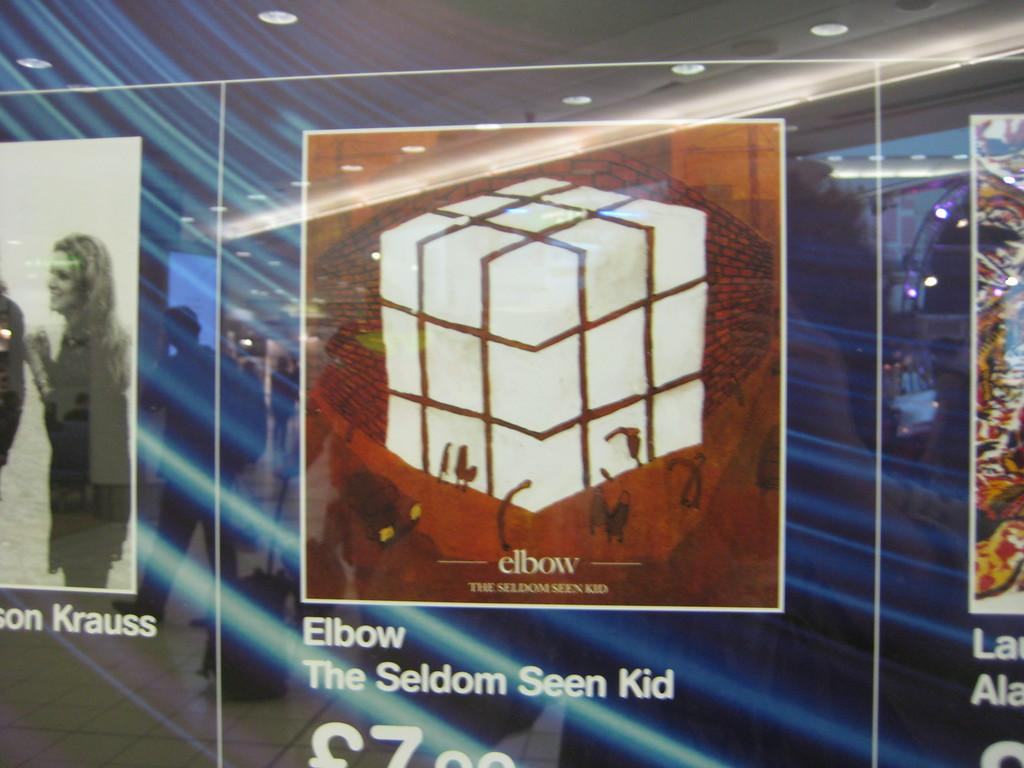<image>
Share a concise interpretation of the image provided. A listing for Elbow by the seldom seen kid with its price being 7.99. 